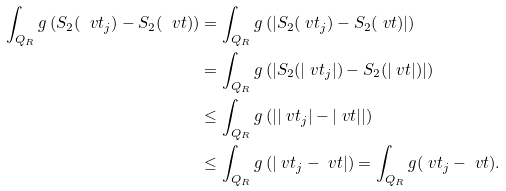Convert formula to latex. <formula><loc_0><loc_0><loc_500><loc_500>\int _ { Q _ { R } } g \left ( S _ { 2 } ( \ v t _ { j } ) - S _ { 2 } ( \ v t ) \right ) & = \int _ { Q _ { R } } g \left ( \left | S _ { 2 } ( \ v t _ { j } ) - S _ { 2 } ( \ v t ) \right | \right ) \\ & = \int _ { Q _ { R } } g \left ( \left | S _ { 2 } ( | \ v t _ { j } | ) - S _ { 2 } ( | \ v t | ) \right | \right ) \\ & \leq \int _ { Q _ { R } } g \left ( \left | | \ v t _ { j } | - | \ v t | \right | \right ) \\ & \leq \int _ { Q _ { R } } g \left ( | \ v t _ { j } - \ v t | \right ) = \int _ { Q _ { R } } g ( \ v t _ { j } - \ v t ) .</formula> 